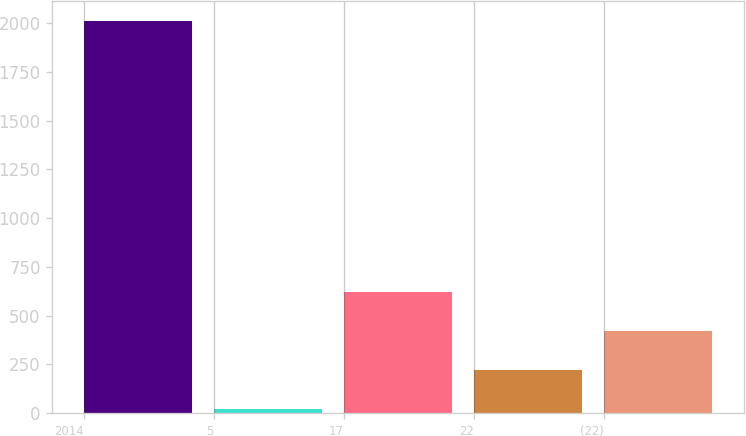<chart> <loc_0><loc_0><loc_500><loc_500><bar_chart><fcel>2014<fcel>5<fcel>17<fcel>22<fcel>(22)<nl><fcel>2013<fcel>21<fcel>618.6<fcel>220.2<fcel>419.4<nl></chart> 